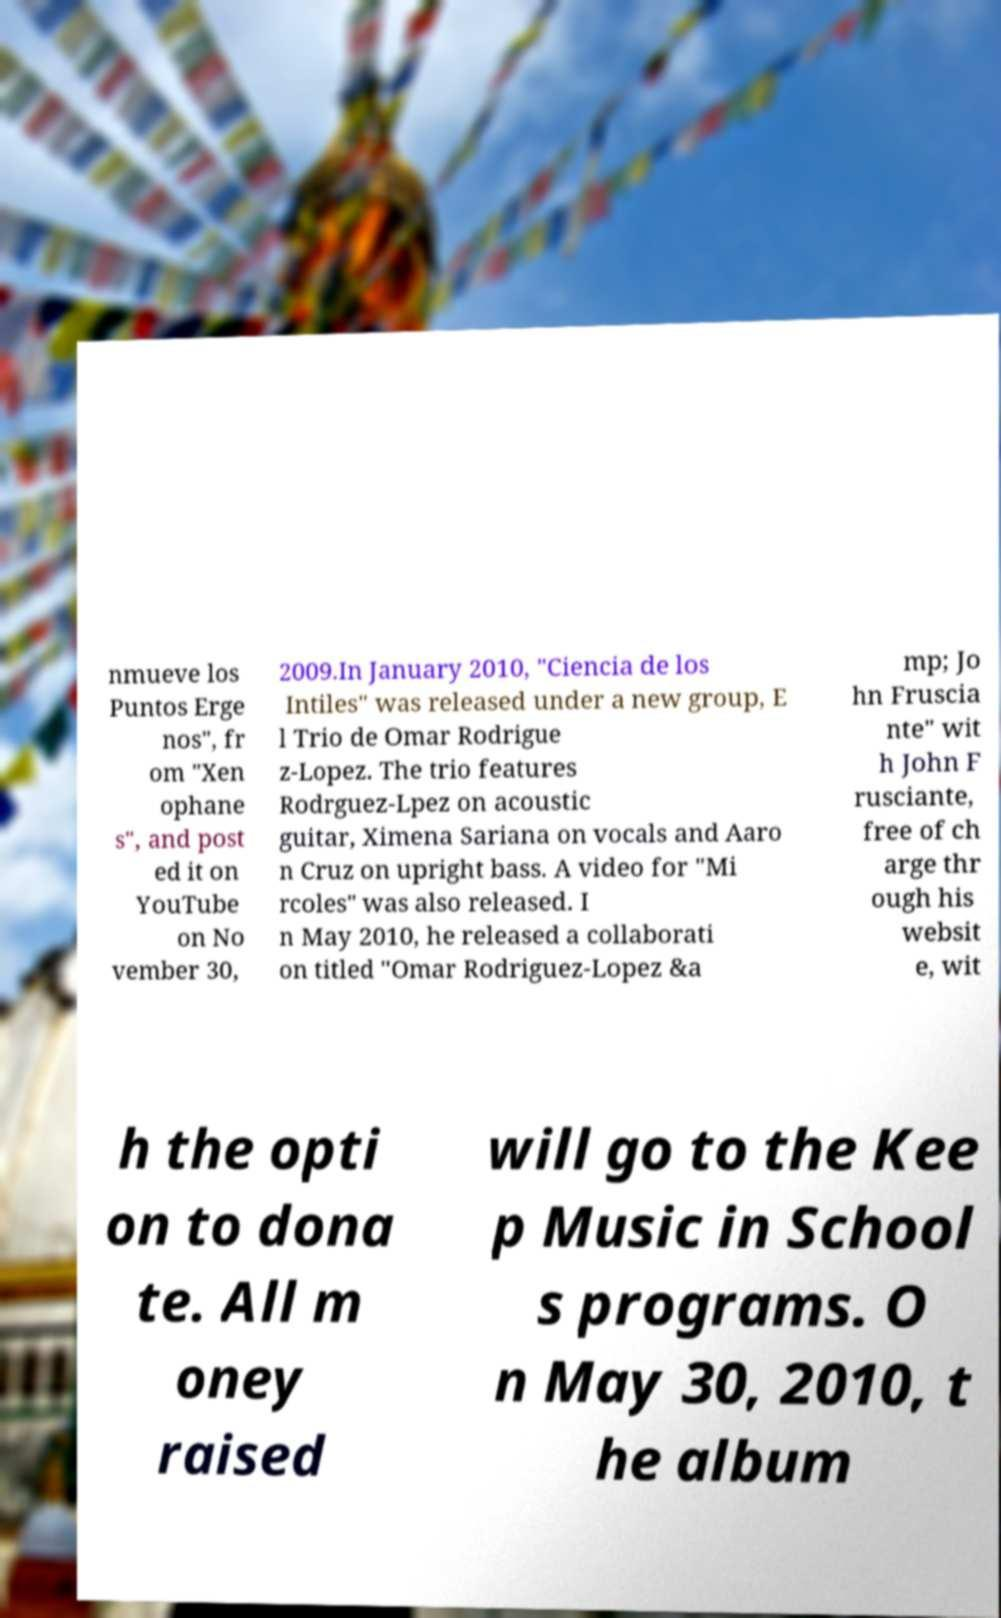For documentation purposes, I need the text within this image transcribed. Could you provide that? nmueve los Puntos Erge nos", fr om "Xen ophane s", and post ed it on YouTube on No vember 30, 2009.In January 2010, "Ciencia de los Intiles" was released under a new group, E l Trio de Omar Rodrigue z-Lopez. The trio features Rodrguez-Lpez on acoustic guitar, Ximena Sariana on vocals and Aaro n Cruz on upright bass. A video for "Mi rcoles" was also released. I n May 2010, he released a collaborati on titled "Omar Rodriguez-Lopez &a mp; Jo hn Fruscia nte" wit h John F rusciante, free of ch arge thr ough his websit e, wit h the opti on to dona te. All m oney raised will go to the Kee p Music in School s programs. O n May 30, 2010, t he album 